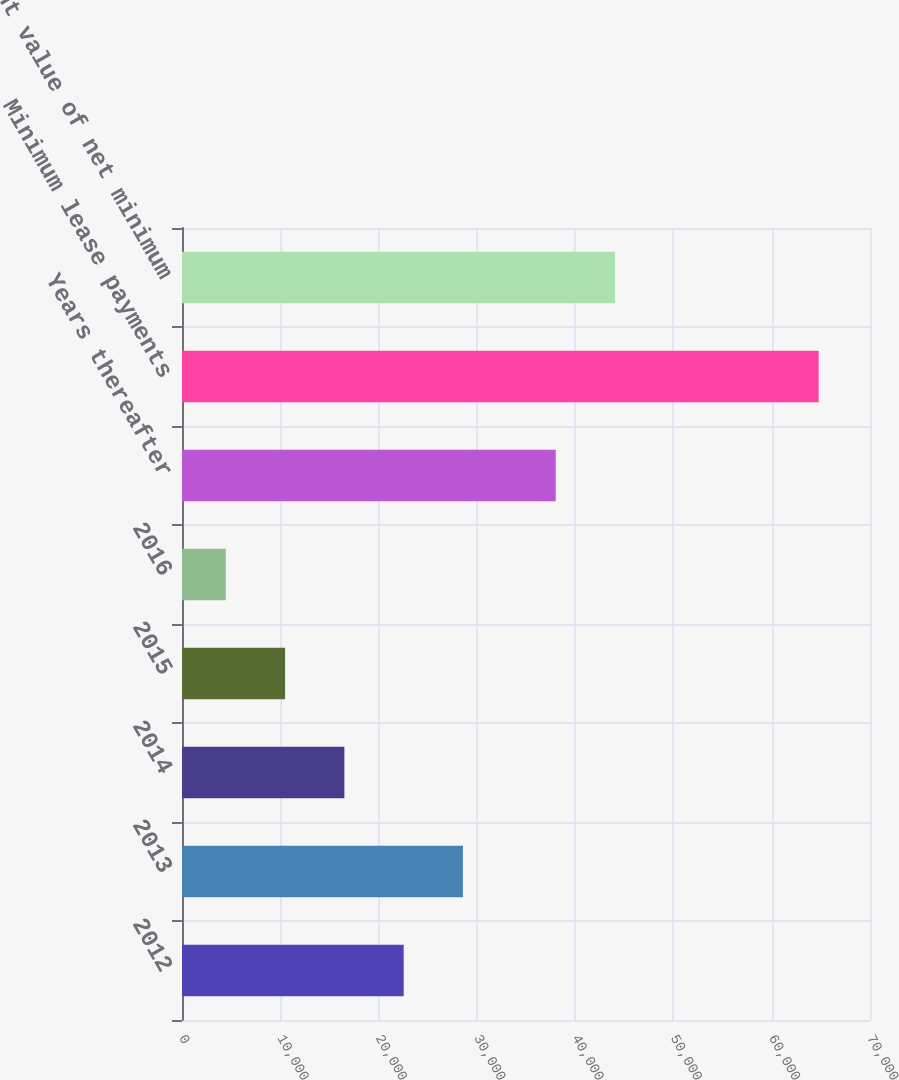<chart> <loc_0><loc_0><loc_500><loc_500><bar_chart><fcel>2012<fcel>2013<fcel>2014<fcel>2015<fcel>2016<fcel>Years thereafter<fcel>Minimum lease payments<fcel>Present value of net minimum<nl><fcel>22553.6<fcel>28585.8<fcel>16521.4<fcel>10489.2<fcel>4457<fcel>38025<fcel>64779<fcel>44057.2<nl></chart> 